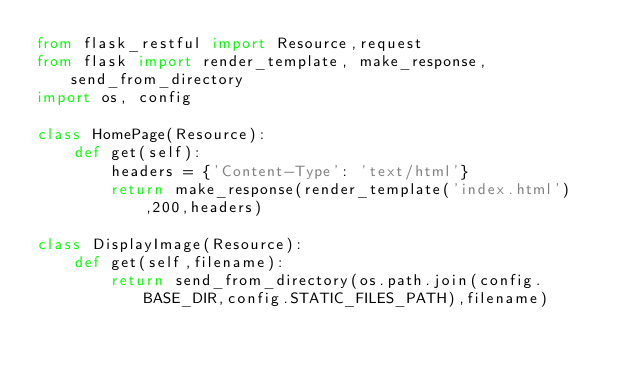<code> <loc_0><loc_0><loc_500><loc_500><_Python_>from flask_restful import Resource,request
from flask import render_template, make_response, send_from_directory
import os, config

class HomePage(Resource):
    def get(self):
        headers = {'Content-Type': 'text/html'}
        return make_response(render_template('index.html'),200,headers)

class DisplayImage(Resource):
    def get(self,filename):
        return send_from_directory(os.path.join(config.BASE_DIR,config.STATIC_FILES_PATH),filename)</code> 